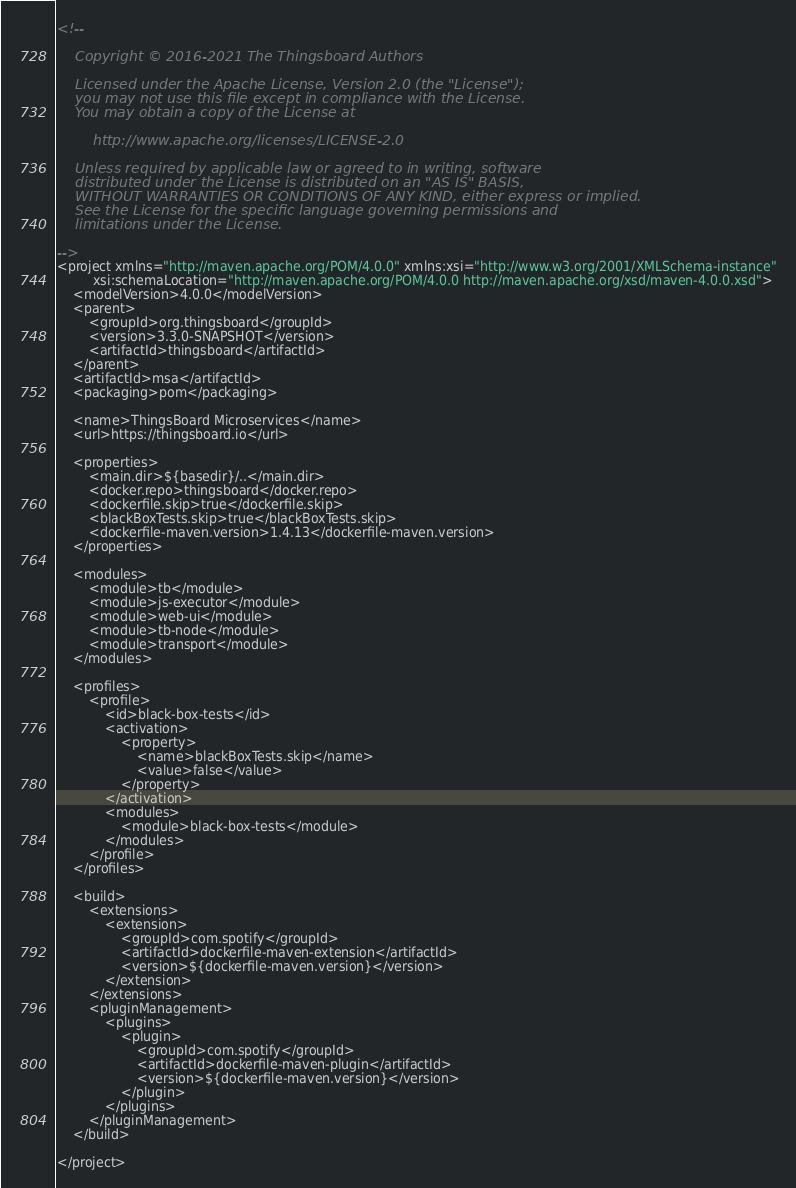<code> <loc_0><loc_0><loc_500><loc_500><_XML_><!--

    Copyright © 2016-2021 The Thingsboard Authors

    Licensed under the Apache License, Version 2.0 (the "License");
    you may not use this file except in compliance with the License.
    You may obtain a copy of the License at

        http://www.apache.org/licenses/LICENSE-2.0

    Unless required by applicable law or agreed to in writing, software
    distributed under the License is distributed on an "AS IS" BASIS,
    WITHOUT WARRANTIES OR CONDITIONS OF ANY KIND, either express or implied.
    See the License for the specific language governing permissions and
    limitations under the License.

-->
<project xmlns="http://maven.apache.org/POM/4.0.0" xmlns:xsi="http://www.w3.org/2001/XMLSchema-instance"
         xsi:schemaLocation="http://maven.apache.org/POM/4.0.0 http://maven.apache.org/xsd/maven-4.0.0.xsd">
    <modelVersion>4.0.0</modelVersion>
    <parent>
        <groupId>org.thingsboard</groupId>
        <version>3.3.0-SNAPSHOT</version>
        <artifactId>thingsboard</artifactId>
    </parent>
    <artifactId>msa</artifactId>
    <packaging>pom</packaging>

    <name>ThingsBoard Microservices</name>
    <url>https://thingsboard.io</url>

    <properties>
        <main.dir>${basedir}/..</main.dir>
        <docker.repo>thingsboard</docker.repo>
        <dockerfile.skip>true</dockerfile.skip>
        <blackBoxTests.skip>true</blackBoxTests.skip>
        <dockerfile-maven.version>1.4.13</dockerfile-maven.version>
    </properties>

    <modules>
        <module>tb</module>
        <module>js-executor</module>
        <module>web-ui</module>
        <module>tb-node</module>
        <module>transport</module>
    </modules>

    <profiles>
        <profile>
            <id>black-box-tests</id>
            <activation>
                <property>
                    <name>blackBoxTests.skip</name>
                    <value>false</value>
                </property>
            </activation>
            <modules>
                <module>black-box-tests</module>
            </modules>
        </profile>
    </profiles>

    <build>
        <extensions>
            <extension>
                <groupId>com.spotify</groupId>
                <artifactId>dockerfile-maven-extension</artifactId>
                <version>${dockerfile-maven.version}</version>
            </extension>
        </extensions>
        <pluginManagement>
            <plugins>
                <plugin>
                    <groupId>com.spotify</groupId>
                    <artifactId>dockerfile-maven-plugin</artifactId>
                    <version>${dockerfile-maven.version}</version>
                </plugin>
            </plugins>
        </pluginManagement>
    </build>

</project>
</code> 